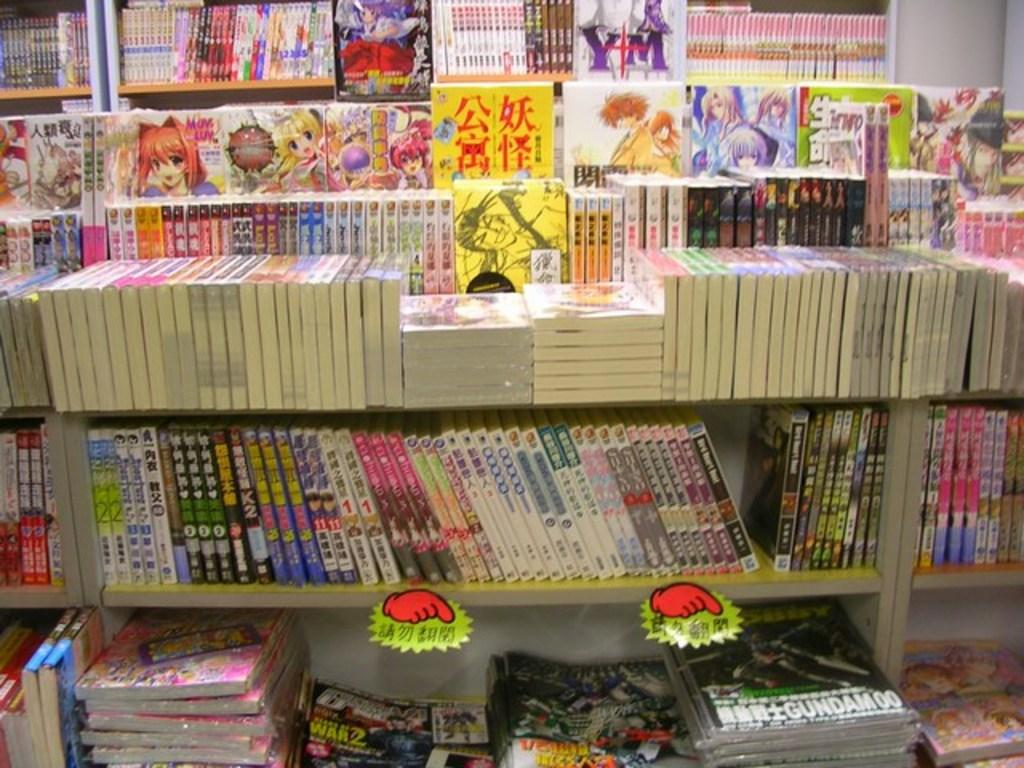Provide a one-sentence caption for the provided image. A lot of books are arranged on a bookshelf in a foreign language. 